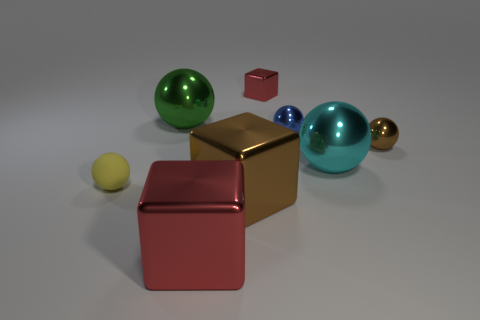Is there another block that has the same color as the tiny cube?
Provide a short and direct response. Yes. There is a red metallic thing that is the same size as the brown sphere; what is its shape?
Offer a very short reply. Cube. Are there any small balls behind the small brown shiny object?
Give a very brief answer. Yes. Does the brown object to the left of the blue metal ball have the same material as the tiny object that is on the left side of the big green shiny sphere?
Keep it short and to the point. No. What number of yellow matte balls are the same size as the cyan thing?
Provide a short and direct response. 0. The metal thing that is the same color as the small shiny cube is what shape?
Make the answer very short. Cube. What material is the small object in front of the cyan metallic ball?
Ensure brevity in your answer.  Rubber. How many small yellow matte things are the same shape as the green thing?
Offer a very short reply. 1. There is a cyan object that is made of the same material as the big red object; what shape is it?
Keep it short and to the point. Sphere. What shape is the red object that is behind the red cube that is in front of the red thing behind the yellow thing?
Provide a succinct answer. Cube. 